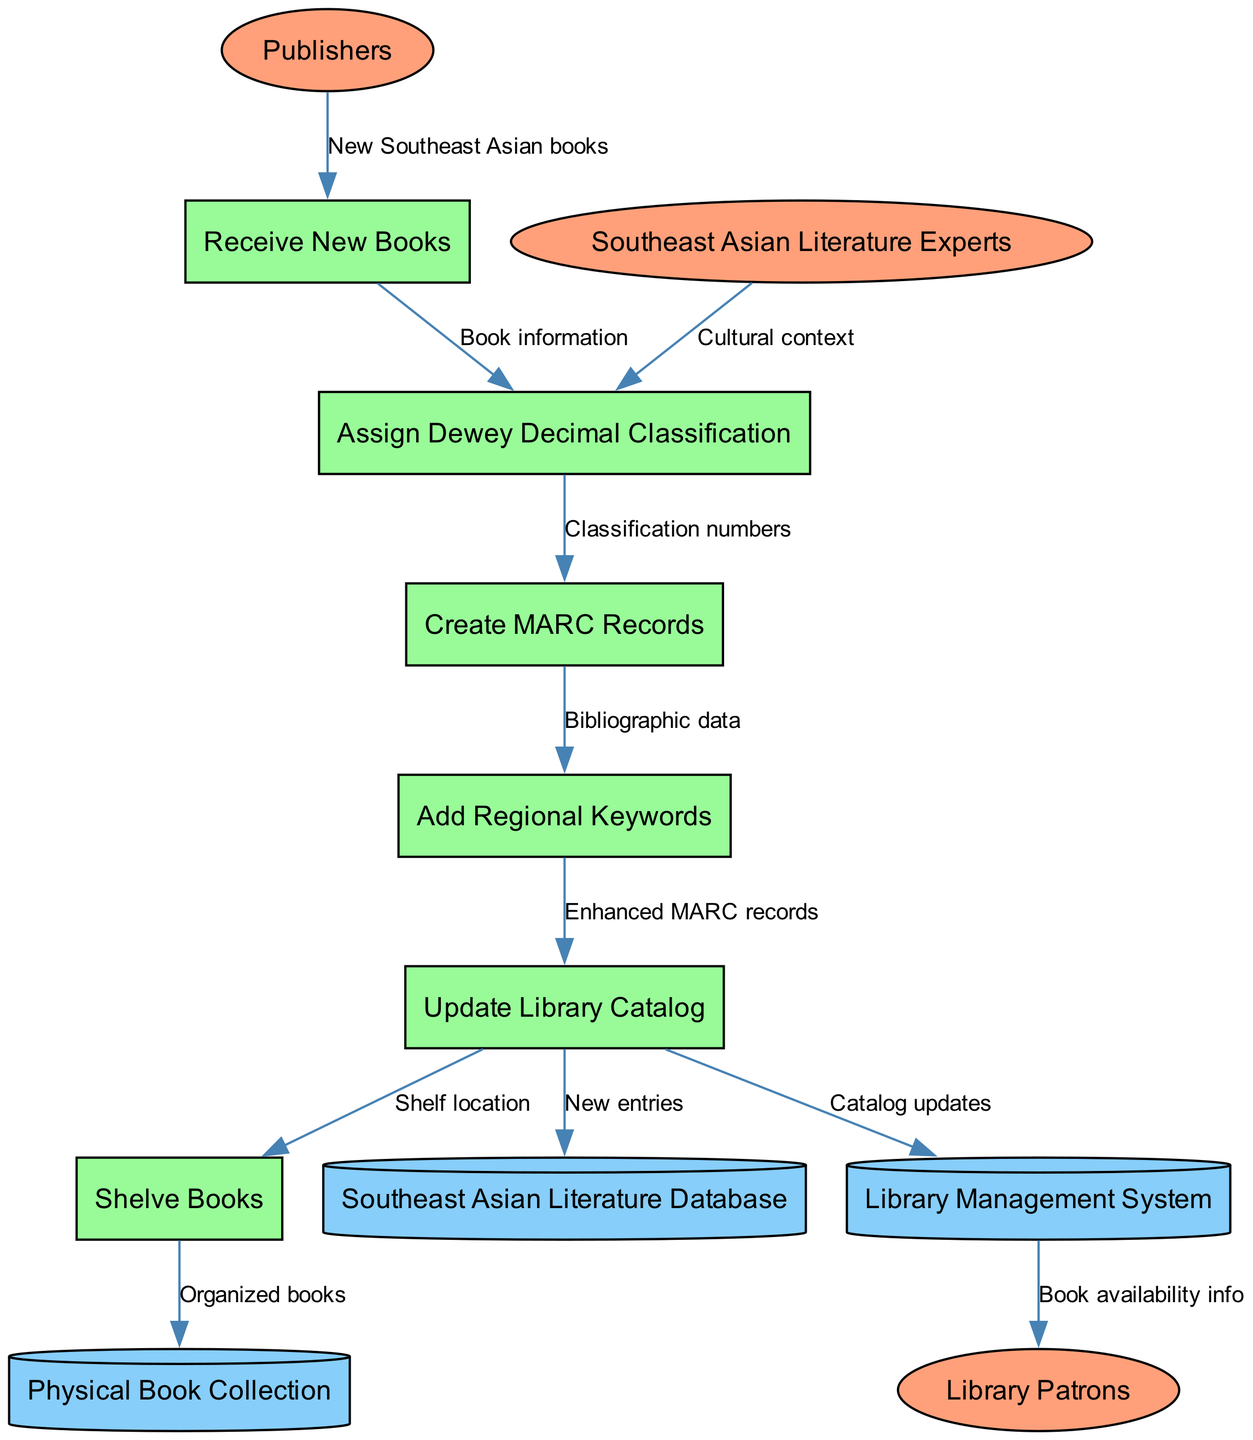What are the external entities involved in the diagram? The external entities represented in the diagram are 'Publishers', 'Southeast Asian Literature Experts', and 'Library Patrons'. Each of these entities interacts with the processes outlined in the diagram.
Answer: Publishers, Southeast Asian Literature Experts, Library Patrons How many processes are represented in the diagram? The diagram shows six processes: 'Receive New Books', 'Assign Dewey Decimal Classification', 'Create MARC Records', 'Add Regional Keywords', 'Update Library Catalog', and 'Shelve Books'.
Answer: Six What is the data flow from 'Create MARC Records' to 'Add Regional Keywords'? The data flow is labeled 'Bibliographic data', indicating the type of information transferred between these two processes.
Answer: Bibliographic data Which process directly receives new books from publishers? The process immediately following the data flow from 'Publishers' is 'Receive New Books'. This indicates it is the first point of processing for incoming literature.
Answer: Receive New Books What data store receives updates from the 'Update Library Catalog' process? The data store that receives updates is 'Southeast Asian Literature Database', which is where new entries from the catalog updates are recorded.
Answer: Southeast Asian Literature Database What type of records are created after assigning Dewey Decimal Classification? After the classification is completed, 'MARC Records' are created as the next step in the workflow.
Answer: MARC Records How does the 'Library Management System' relate to library patrons? The 'Library Management System' provides 'Book availability info' to 'Library Patrons', connecting patrons with the library's resources.
Answer: Book availability info What is the final status of books after the 'Shelve Books' process? The final status is 'Organized books', which indicates that the books have been properly shelved after the cataloging process.
Answer: Organized books 